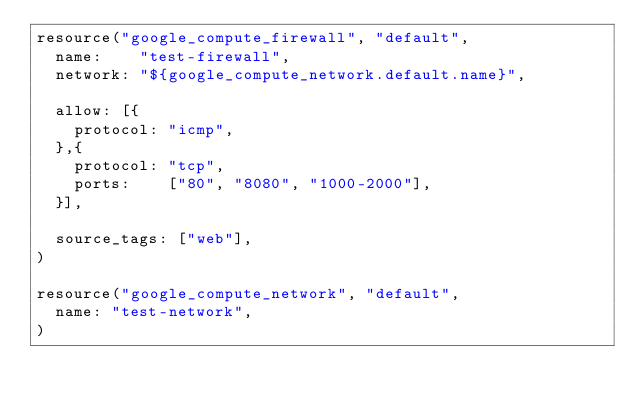Convert code to text. <code><loc_0><loc_0><loc_500><loc_500><_Ruby_>resource("google_compute_firewall", "default",
  name:    "test-firewall",
  network: "${google_compute_network.default.name}",

  allow: [{
    protocol: "icmp",
  },{
    protocol: "tcp",
    ports:    ["80", "8080", "1000-2000"],
  }],

  source_tags: ["web"],
)

resource("google_compute_network", "default",
  name: "test-network",
)
</code> 